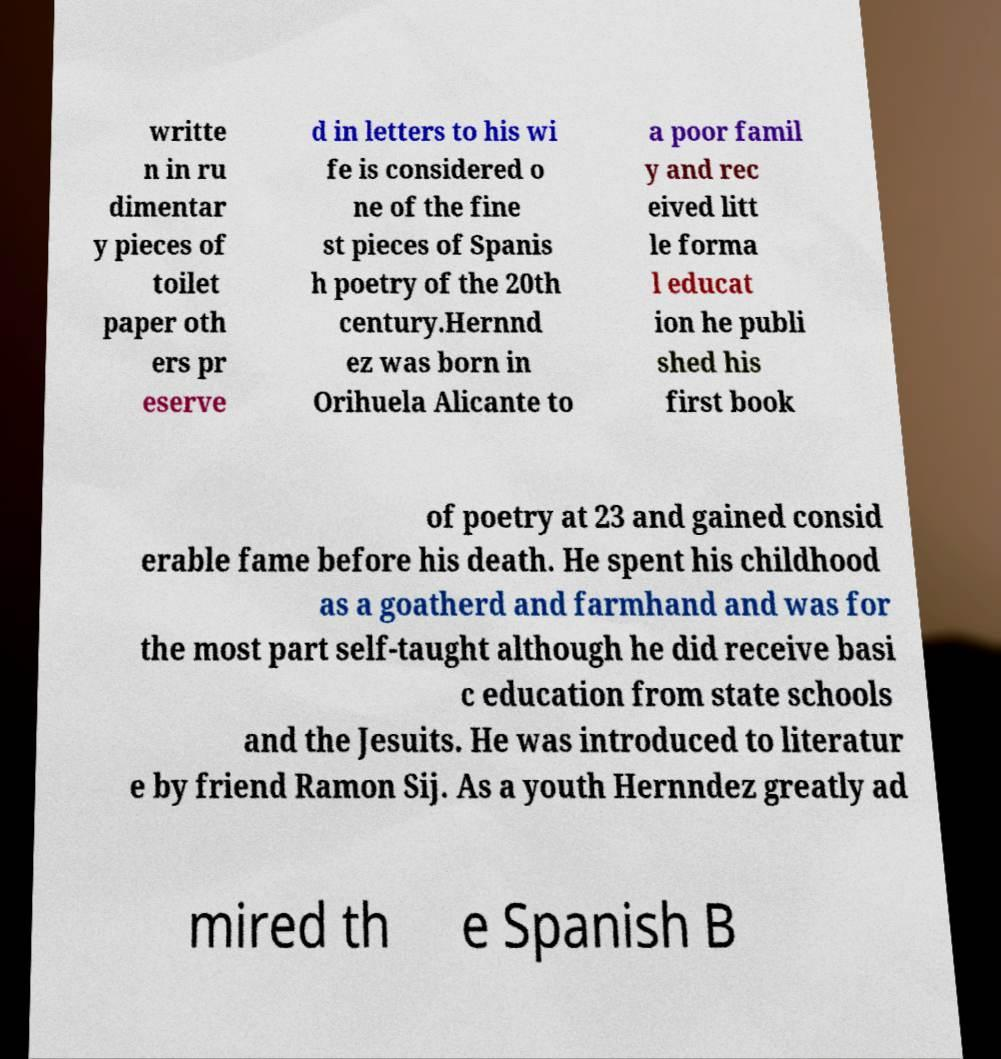There's text embedded in this image that I need extracted. Can you transcribe it verbatim? writte n in ru dimentar y pieces of toilet paper oth ers pr eserve d in letters to his wi fe is considered o ne of the fine st pieces of Spanis h poetry of the 20th century.Hernnd ez was born in Orihuela Alicante to a poor famil y and rec eived litt le forma l educat ion he publi shed his first book of poetry at 23 and gained consid erable fame before his death. He spent his childhood as a goatherd and farmhand and was for the most part self-taught although he did receive basi c education from state schools and the Jesuits. He was introduced to literatur e by friend Ramon Sij. As a youth Hernndez greatly ad mired th e Spanish B 